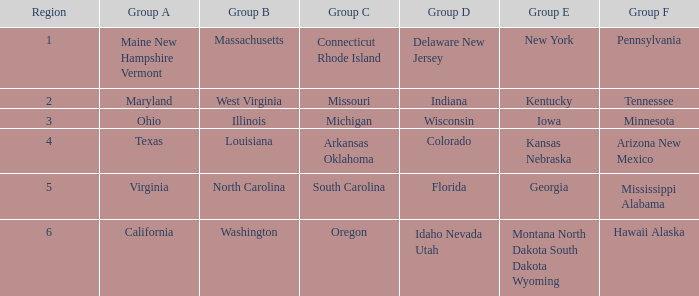What is the group a area with an area number of 2? Maryland. Write the full table. {'header': ['Region', 'Group A', 'Group B', 'Group C', 'Group D', 'Group E', 'Group F'], 'rows': [['1', 'Maine New Hampshire Vermont', 'Massachusetts', 'Connecticut Rhode Island', 'Delaware New Jersey', 'New York', 'Pennsylvania'], ['2', 'Maryland', 'West Virginia', 'Missouri', 'Indiana', 'Kentucky', 'Tennessee'], ['3', 'Ohio', 'Illinois', 'Michigan', 'Wisconsin', 'Iowa', 'Minnesota'], ['4', 'Texas', 'Louisiana', 'Arkansas Oklahoma', 'Colorado', 'Kansas Nebraska', 'Arizona New Mexico'], ['5', 'Virginia', 'North Carolina', 'South Carolina', 'Florida', 'Georgia', 'Mississippi Alabama'], ['6', 'California', 'Washington', 'Oregon', 'Idaho Nevada Utah', 'Montana North Dakota South Dakota Wyoming', 'Hawaii Alaska']]} 